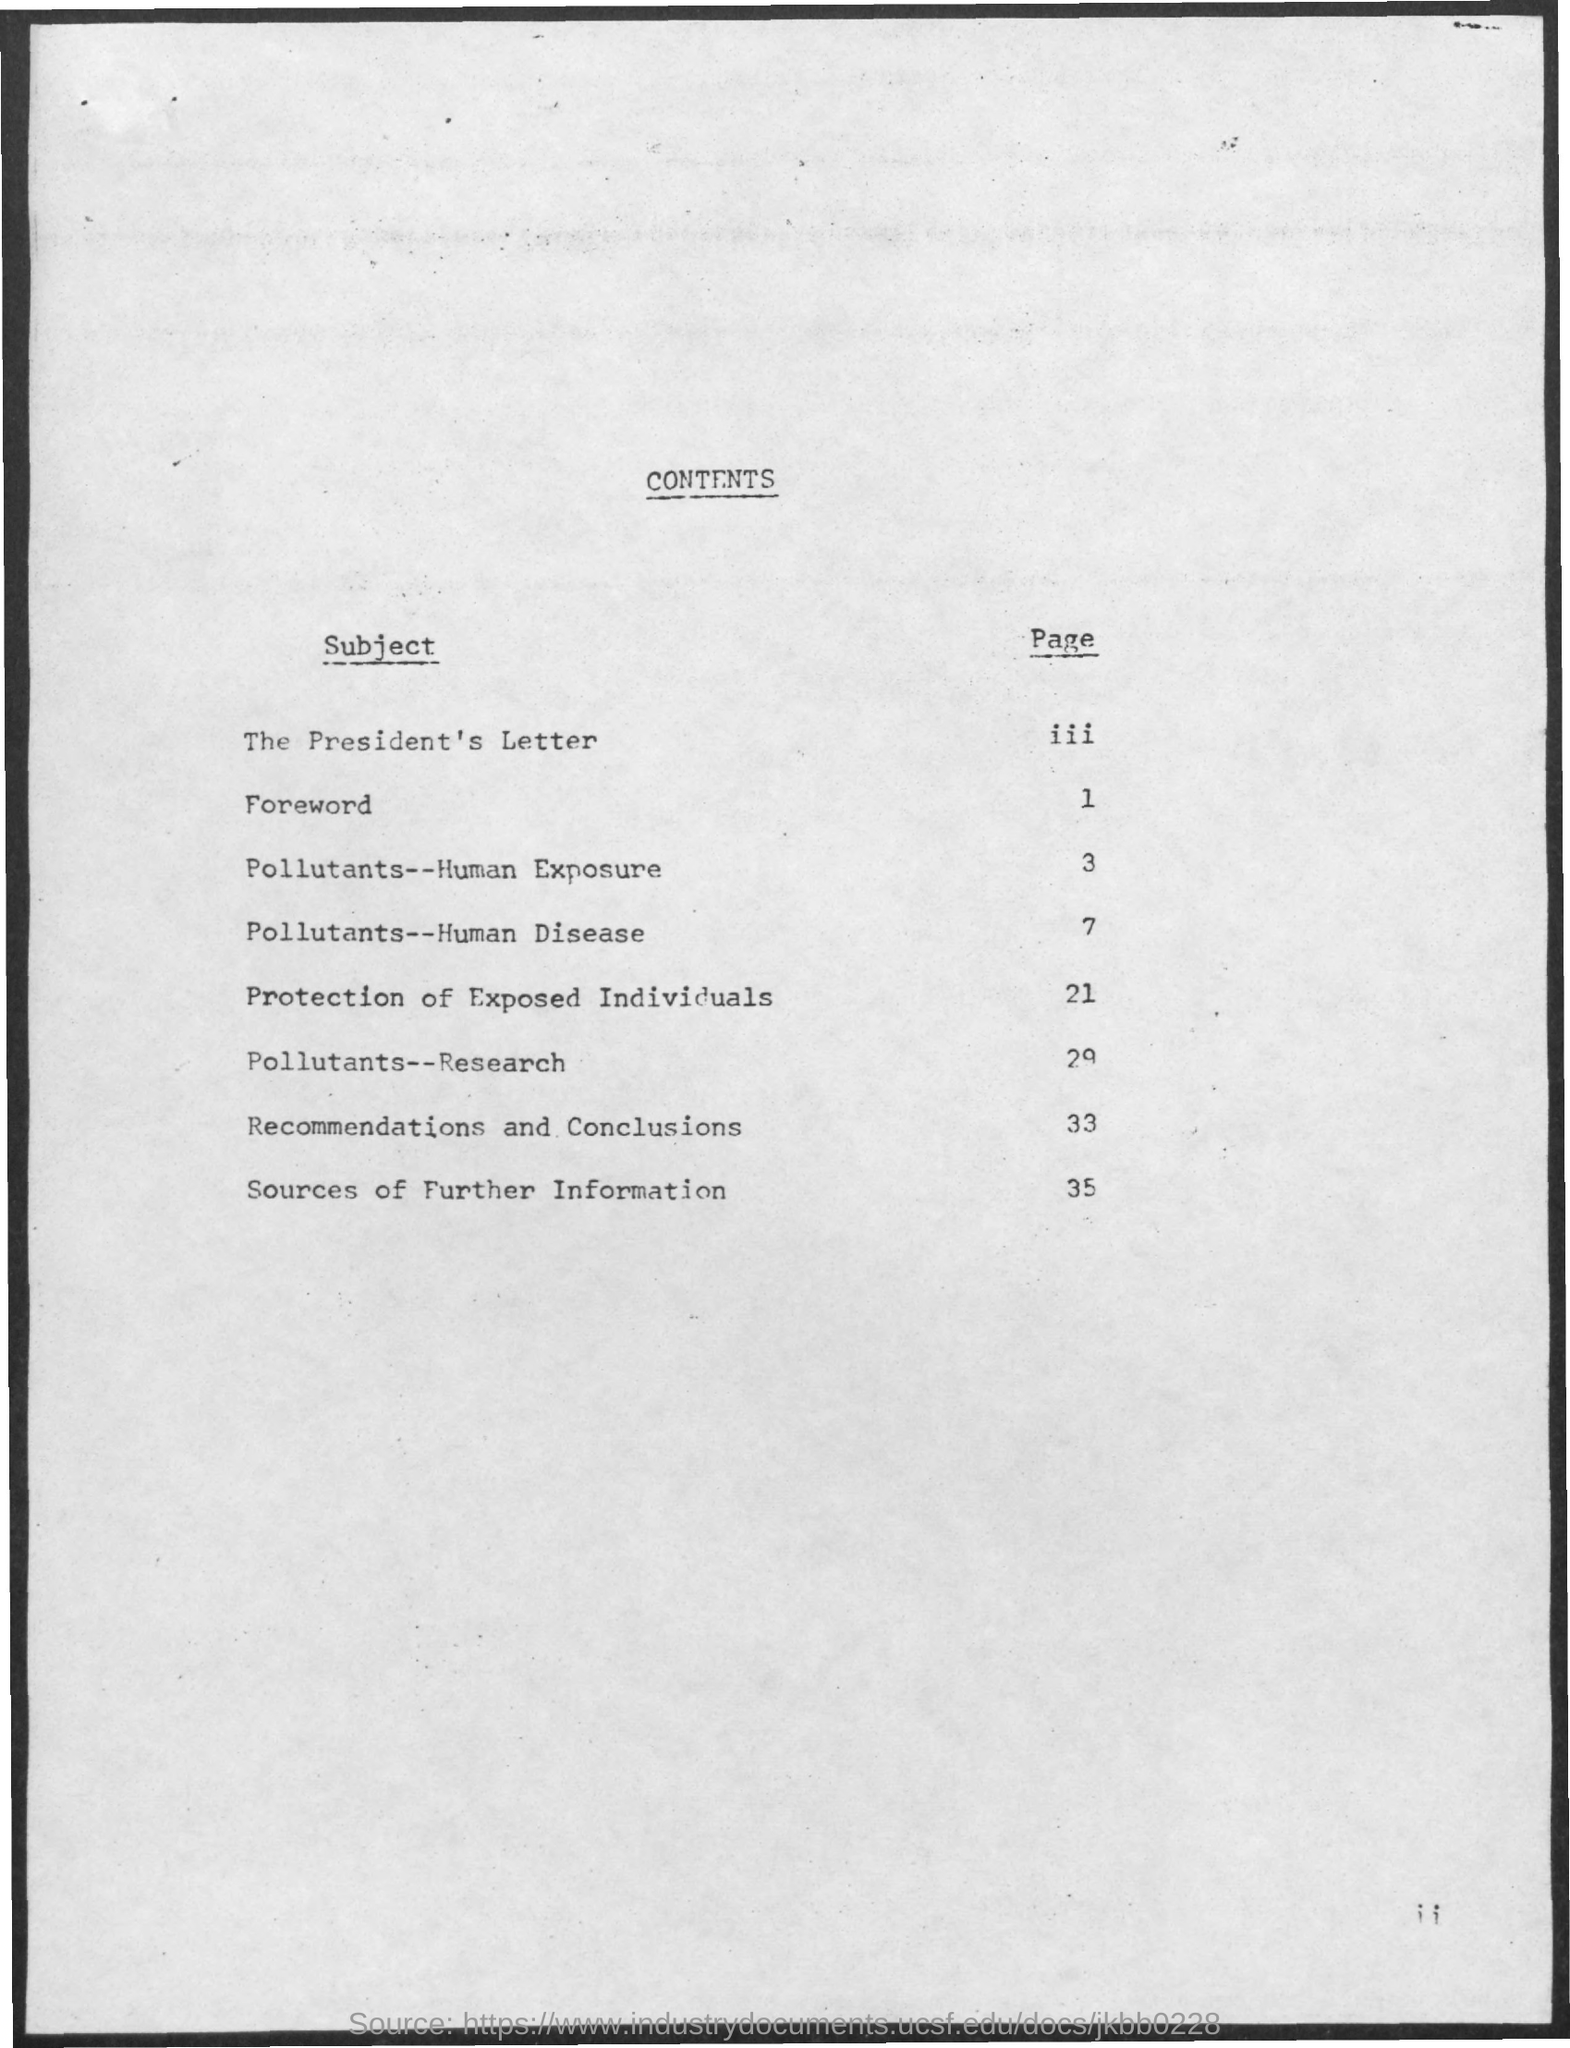what is the page no. for protection of exposed individuals subject? The subject 'Protection of Exposed Individuals' can be found starting on page 21 of the document as listed in the table of contents. 